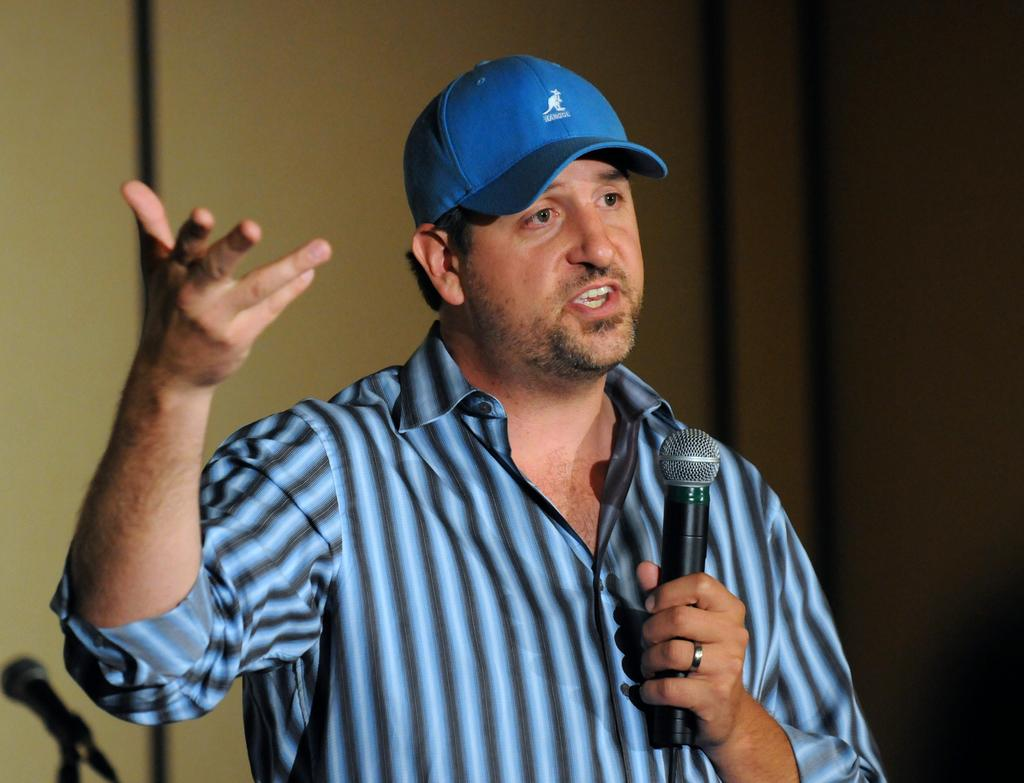What is the main subject of the image? There is a person in the image. What is the person holding in their hand? The person is holding a microphone in their hand. What type of headwear is the person wearing? The person is wearing a cap on their head. What is the person's mouth doing in the image? The person's mouth is open. What type of amusement can be seen in the image? There is no amusement present in the image; it features a person holding a microphone and wearing a cap. What type of instrument is the person playing in the image? The person is not playing an instrument in the image; they are holding a microphone. 